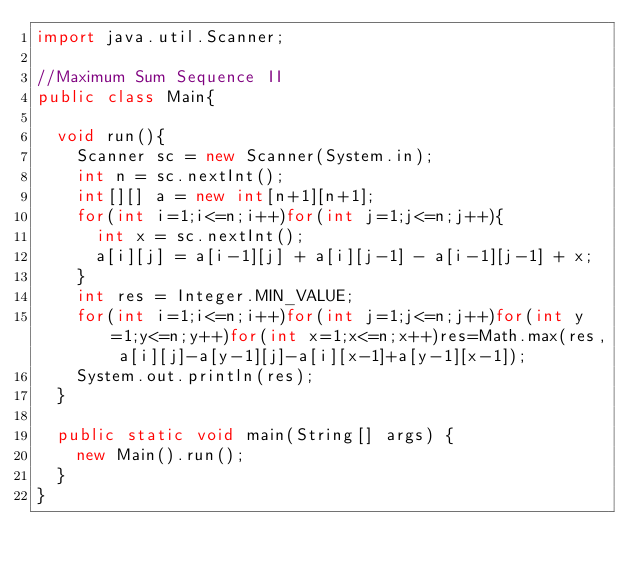<code> <loc_0><loc_0><loc_500><loc_500><_Java_>import java.util.Scanner;

//Maximum Sum Sequence II
public class Main{

	void run(){
		Scanner sc = new Scanner(System.in);
		int n = sc.nextInt();
		int[][] a = new int[n+1][n+1];
		for(int i=1;i<=n;i++)for(int j=1;j<=n;j++){
			int x = sc.nextInt();
			a[i][j] = a[i-1][j] + a[i][j-1] - a[i-1][j-1] + x;
		}
		int res = Integer.MIN_VALUE;
		for(int i=1;i<=n;i++)for(int j=1;j<=n;j++)for(int y=1;y<=n;y++)for(int x=1;x<=n;x++)res=Math.max(res, a[i][j]-a[y-1][j]-a[i][x-1]+a[y-1][x-1]);
		System.out.println(res);
	}
	
	public static void main(String[] args) {
		new Main().run();
	}
}</code> 